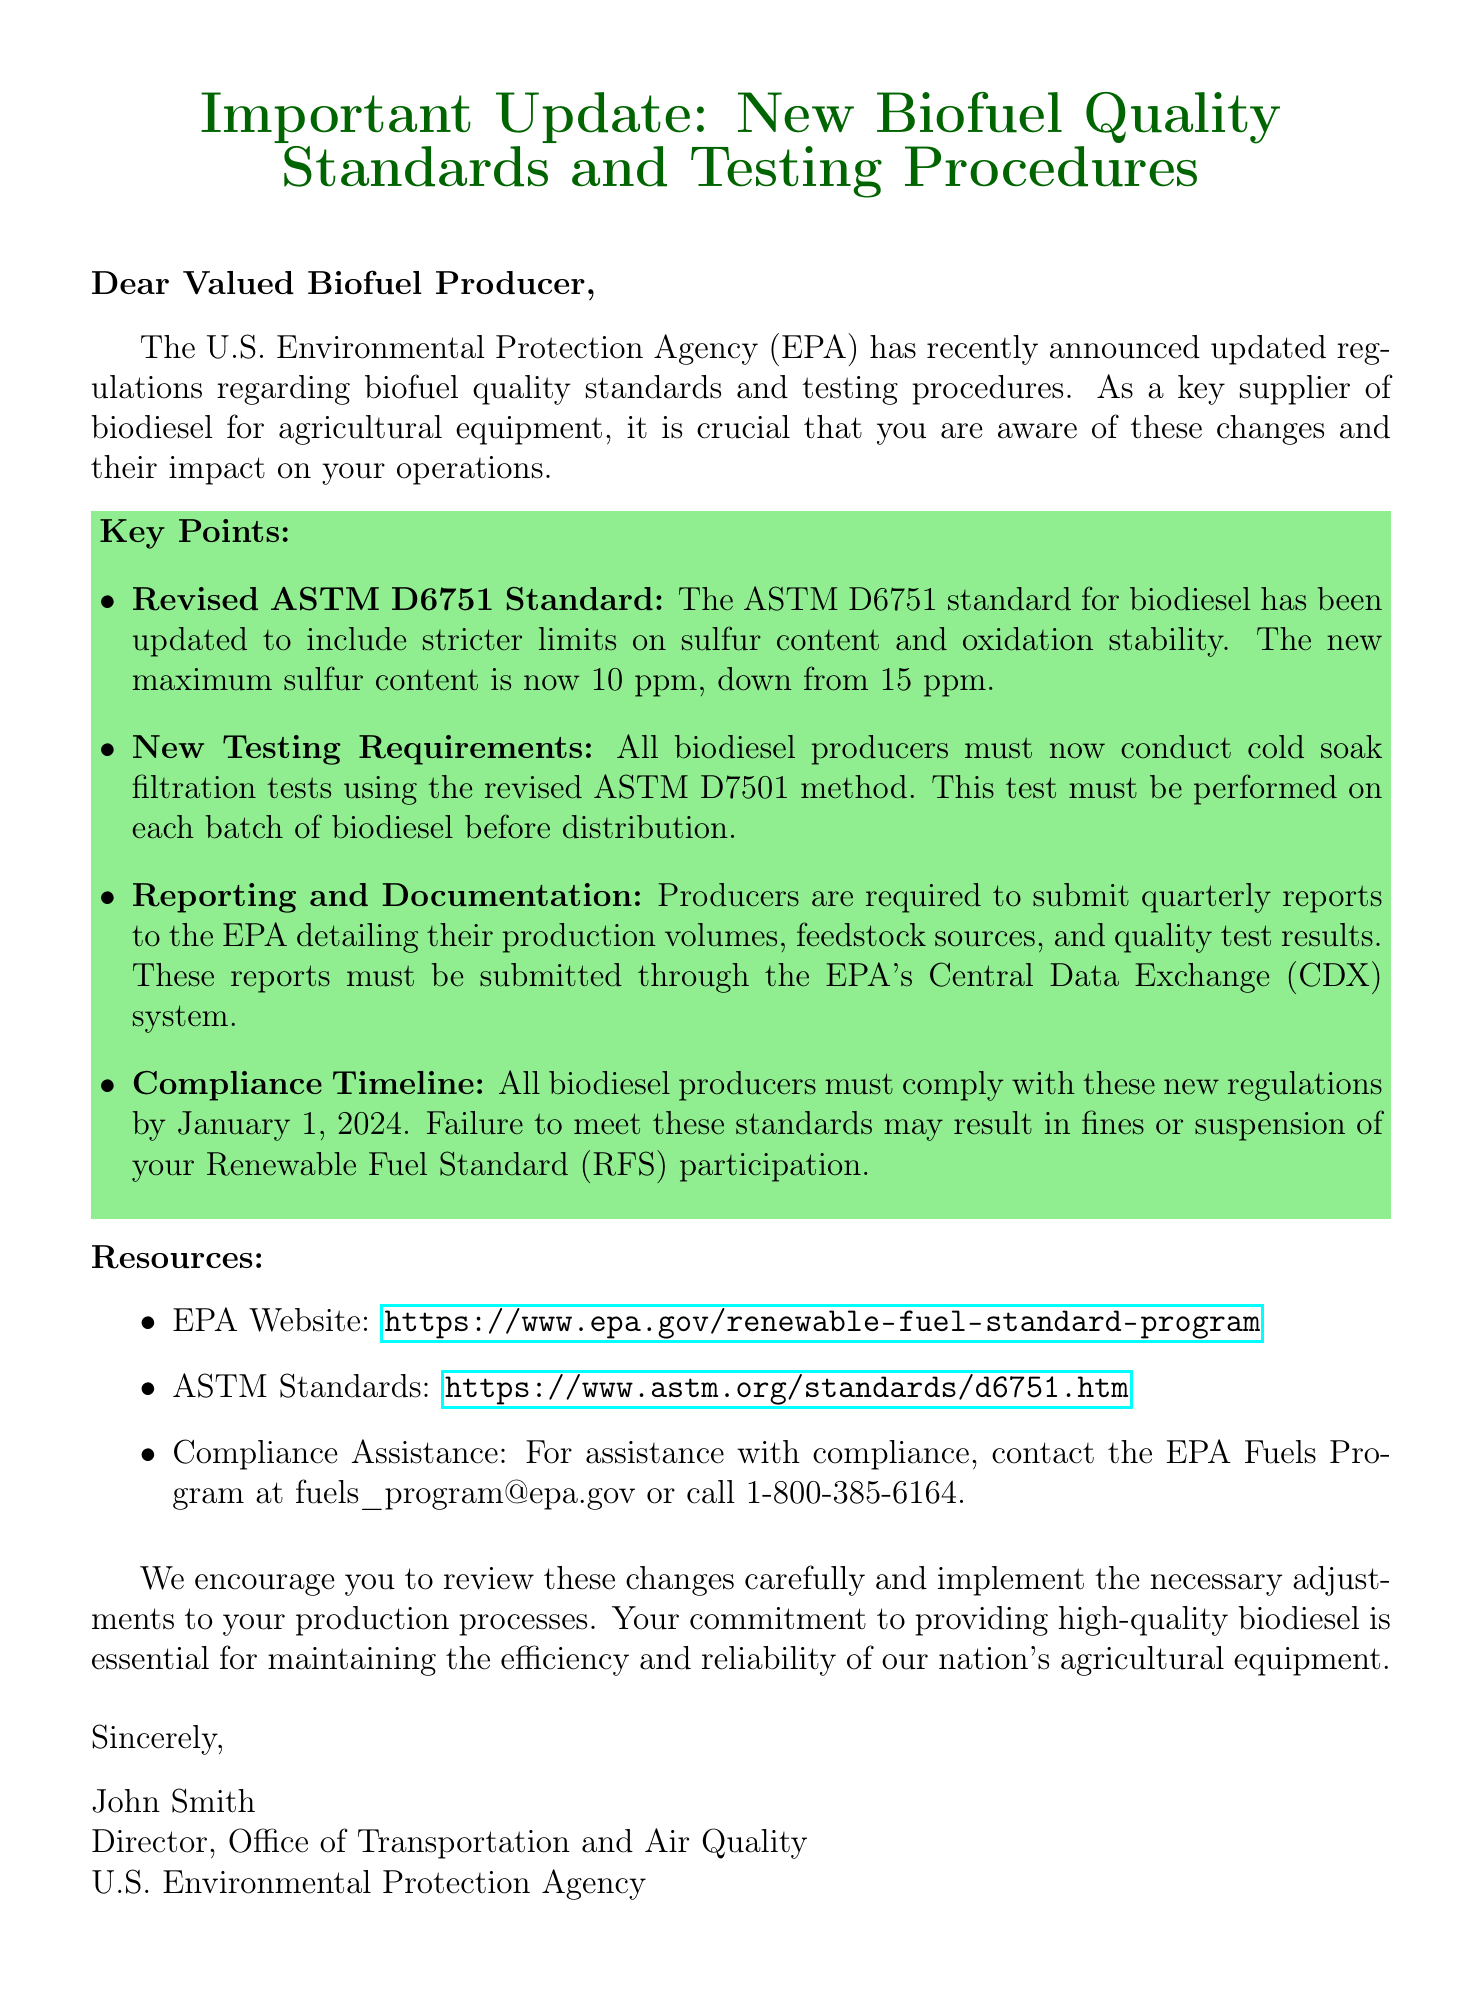What is the new maximum sulfur content? The document states that the new maximum sulfur content is now 10 ppm, down from 15 ppm.
Answer: 10 ppm When must producers comply with the new regulations? The document specifies that all biodiesel producers must comply by January 1, 2024.
Answer: January 1, 2024 What method must be used for cold soak filtration tests? The document mentions that the revised ASTM D7501 method must be used for cold soak filtration tests.
Answer: ASTM D7501 Who should be contacted for compliance assistance? The document provides an email address for assistance, which is fuels_program@epa.gov.
Answer: fuels_program@epa.gov What is required in quarterly reports to the EPA? According to the document, producers must detail their production volumes, feedstock sources, and quality test results in their reports.
Answer: Production volumes, feedstock sources, and quality test results What is the title of the person who signed the document? The document states that the person who signed is the Director, Office of Transportation and Air Quality.
Answer: Director, Office of Transportation and Air Quality What is the purpose of the document? The introduction clearly states that the document informs biofuel producers about updated regulations regarding biofuel quality standards and testing procedures.
Answer: Inform biofuel producers about updated regulations What is the main topic of the key points section? The key points section outlines updated regulations regarding biofuel quality standards and testing requirements.
Answer: Updated regulations regarding biofuel quality standards and testing requirements 